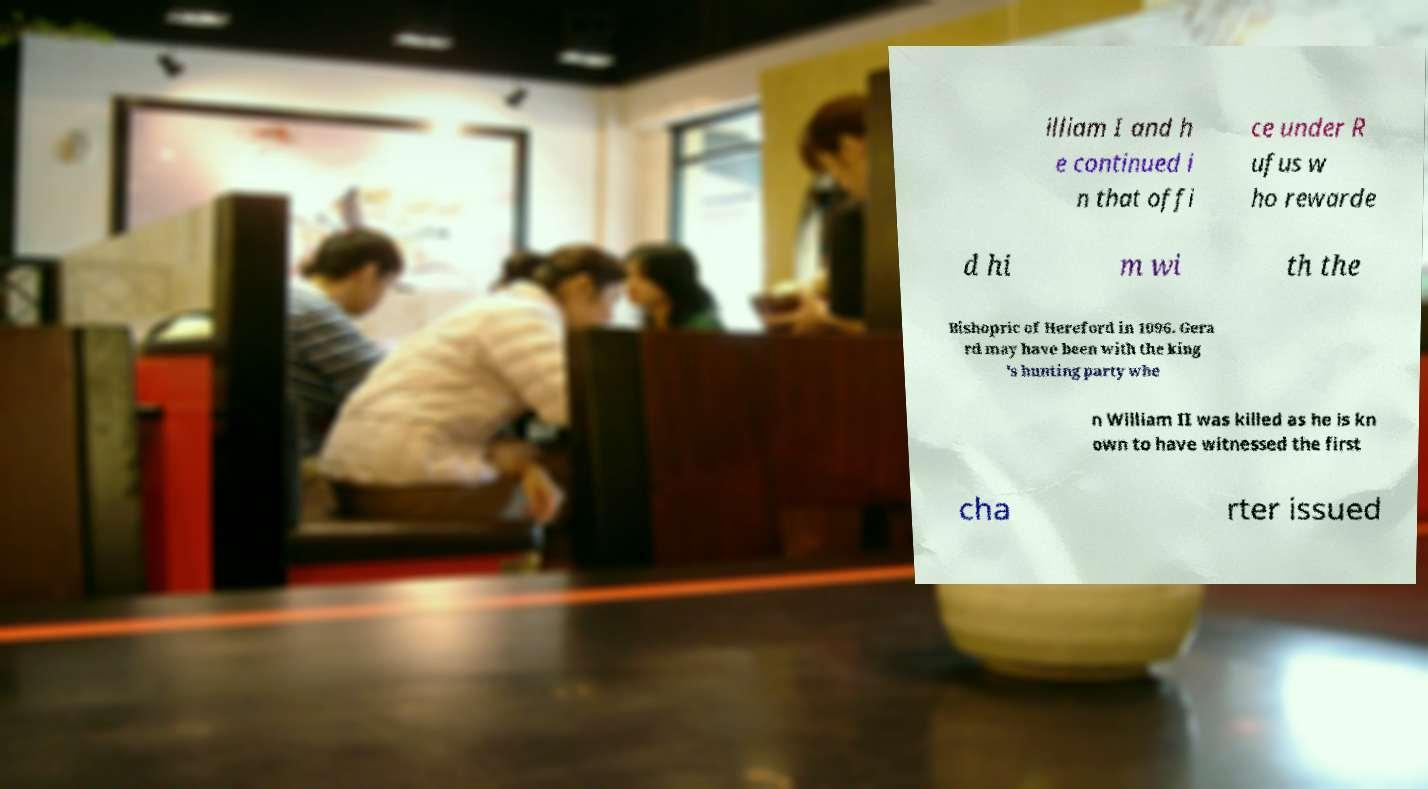For documentation purposes, I need the text within this image transcribed. Could you provide that? illiam I and h e continued i n that offi ce under R ufus w ho rewarde d hi m wi th the Bishopric of Hereford in 1096. Gera rd may have been with the king 's hunting party whe n William II was killed as he is kn own to have witnessed the first cha rter issued 